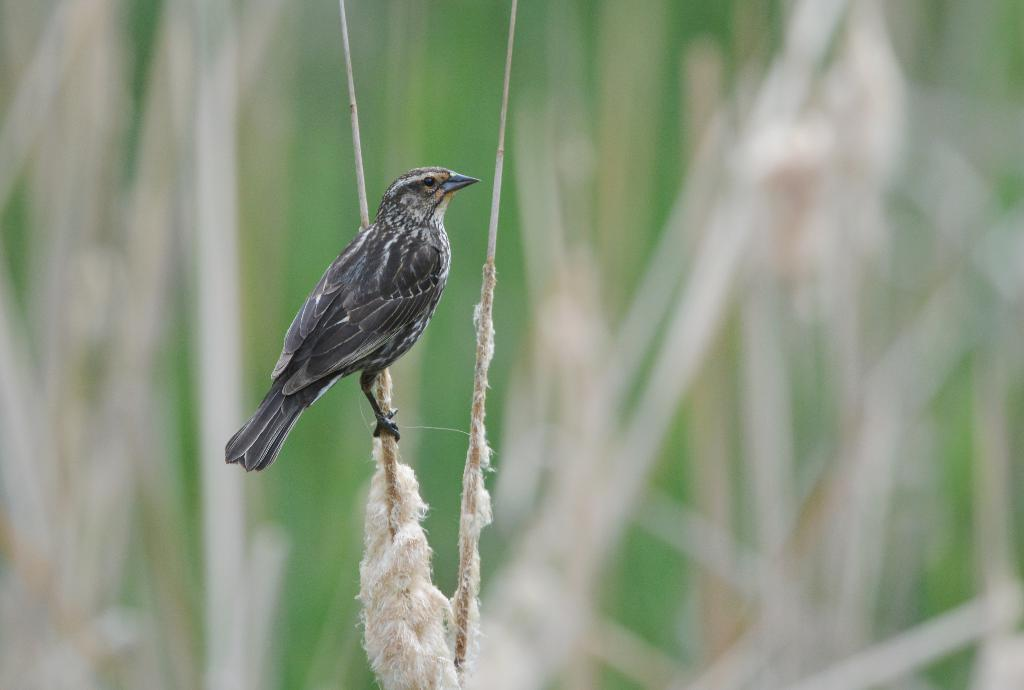What type of animal is in the image? There is a bird in the image. What is the bird perched on? The bird is on a stick. Can you describe the background of the image? The background of the image is blurry. Are there any other sticks visible in the image? Yes, there is another stick visible in the image. What type of quince is being used as a pin for the bird's vacation in the image? There is no quince or mention of a vacation in the image; it features a bird on a stick with a blurry background. 